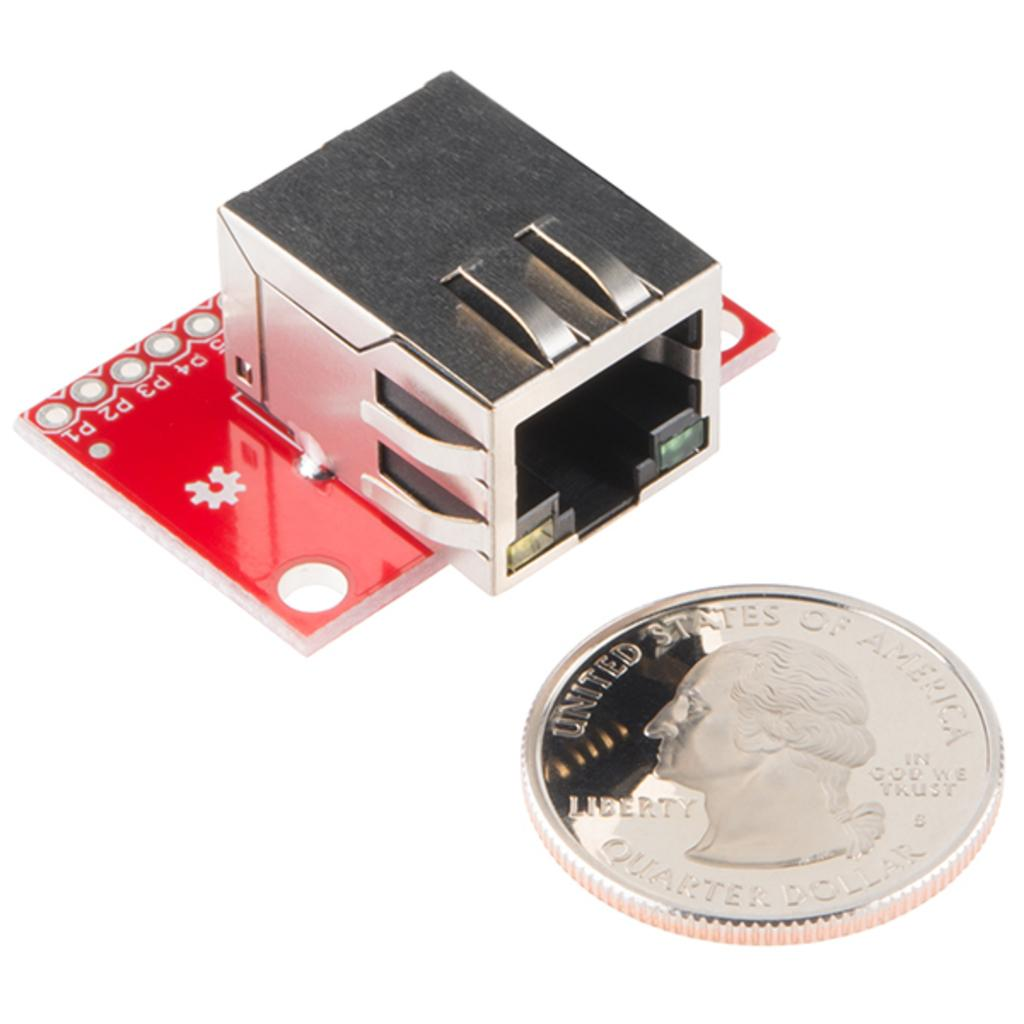<image>
Offer a succinct explanation of the picture presented. A shiny coin with "United States of America' printed at the top. 